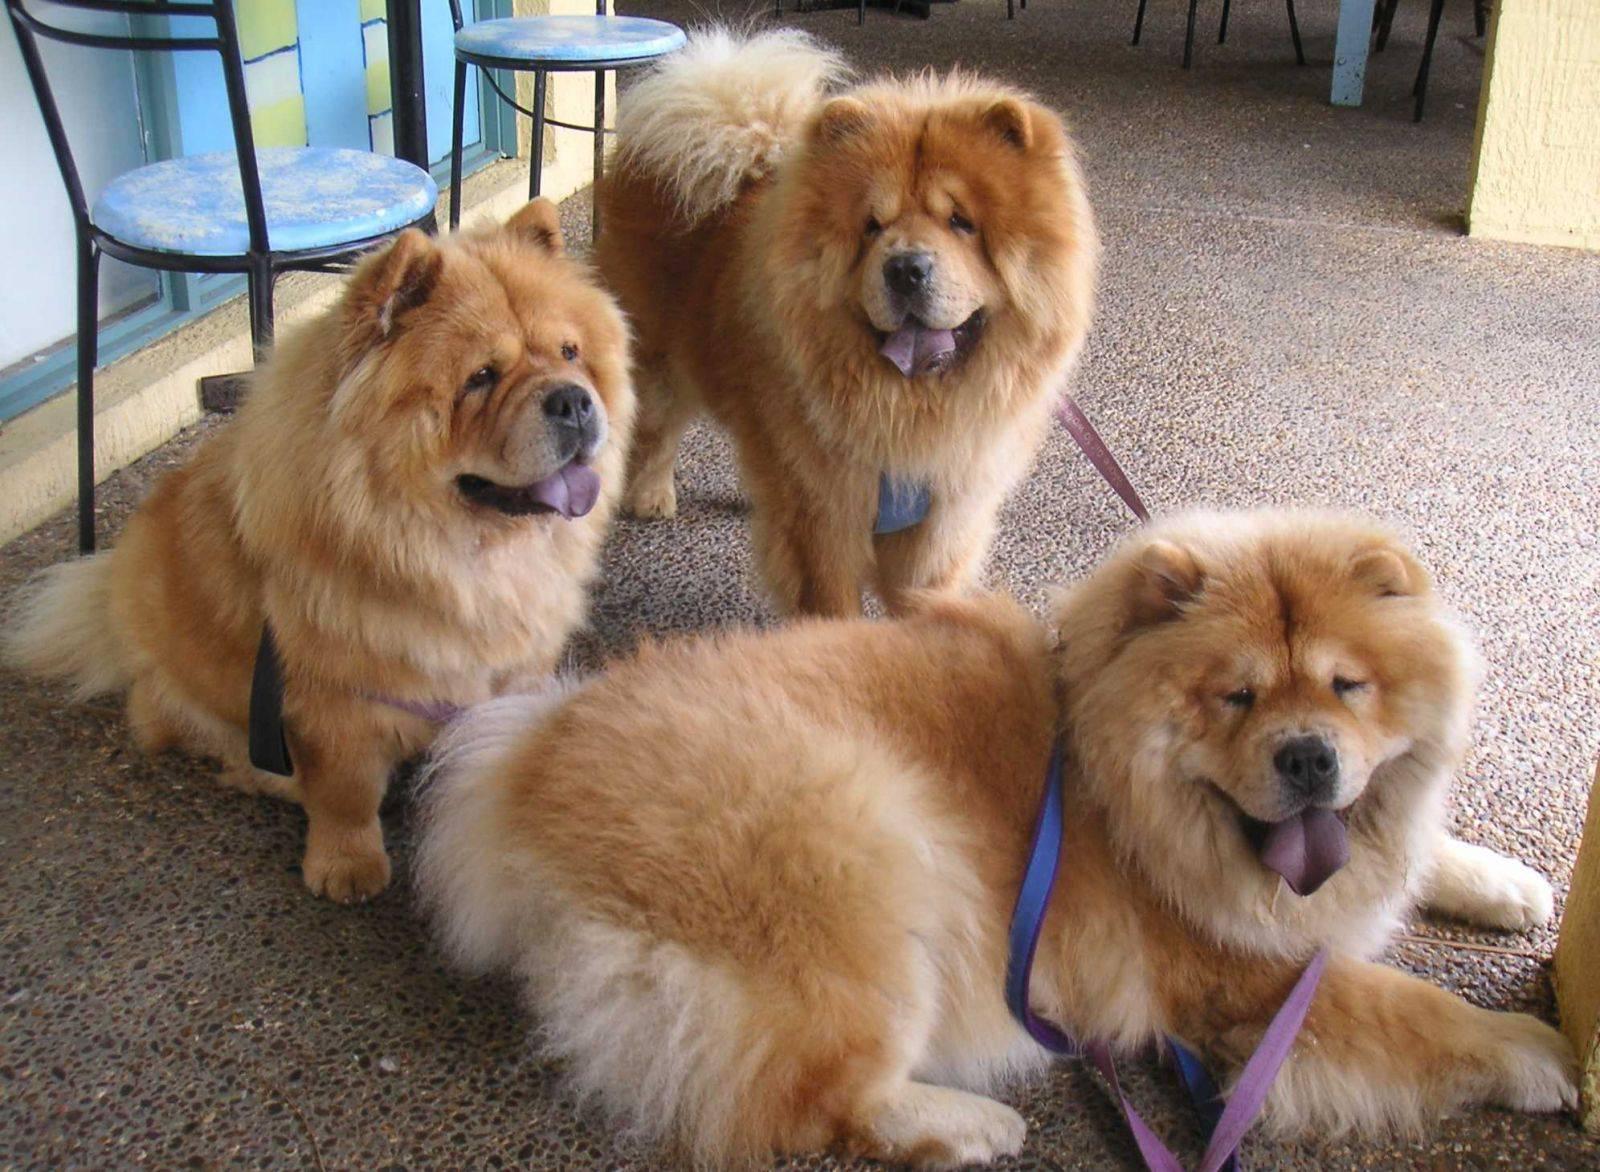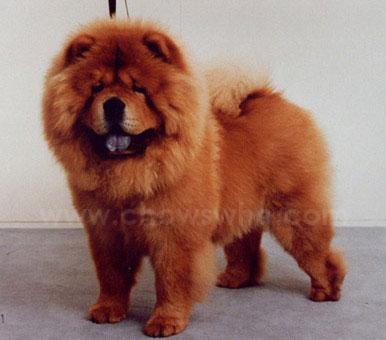The first image is the image on the left, the second image is the image on the right. Examine the images to the left and right. Is the description "Each image contains exactly one chow dog, and at least one image shows a dog standing in profile on grass." accurate? Answer yes or no. No. The first image is the image on the left, the second image is the image on the right. Considering the images on both sides, is "There two dogs in total." valid? Answer yes or no. No. 